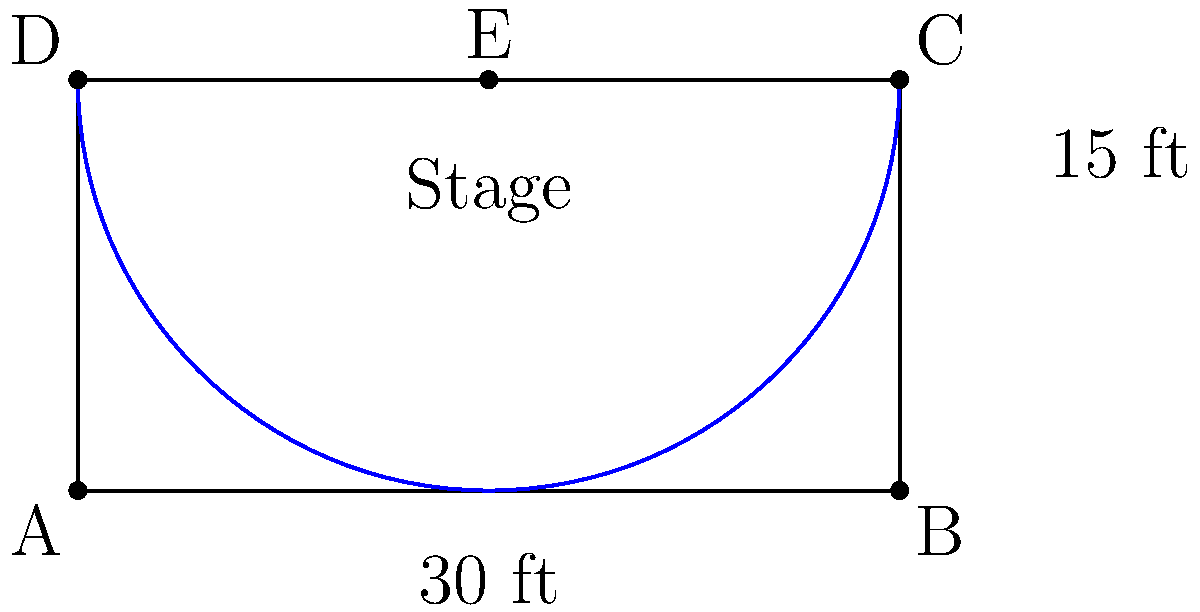You're organizing a book signing event in a rectangular space with a semicircular stage at one end. The rectangular area is 30 feet wide and 15 feet deep, and the stage is a perfect semicircle centered on the back wall. What is the total perimeter of the event space, including the curved edge of the stage? Let's break this down step-by-step:

1) First, let's identify the parts of the perimeter:
   - Two long sides of the rectangle
   - One short side of the rectangle (the front)
   - The semicircular stage

2) The long sides of the rectangle:
   - Each long side is 15 ft
   - There are two of these: $2 \times 15 \text{ ft} = 30 \text{ ft}$

3) The front (short side) of the rectangle:
   - This is given as 30 ft

4) The semicircular stage:
   - The diameter of the semicircle is the width of the rectangle, 30 ft
   - The radius is therefore 15 ft
   - The formula for the circumference of a circle is $2\pi r$
   - For a semicircle, we use half of this: $\pi r$
   - So the length of the curved edge is: $\pi \times 15 \text{ ft} = 15\pi \text{ ft}$

5) Now, let's add all these parts together:
   $\text{Total Perimeter} = 30 \text{ ft} + 30 \text{ ft} + 15\pi \text{ ft}$

6) Simplifying:
   $\text{Total Perimeter} = 60 + 15\pi \text{ ft}$

Therefore, the total perimeter of the event space is $60 + 15\pi$ feet.
Answer: $60 + 15\pi$ feet 